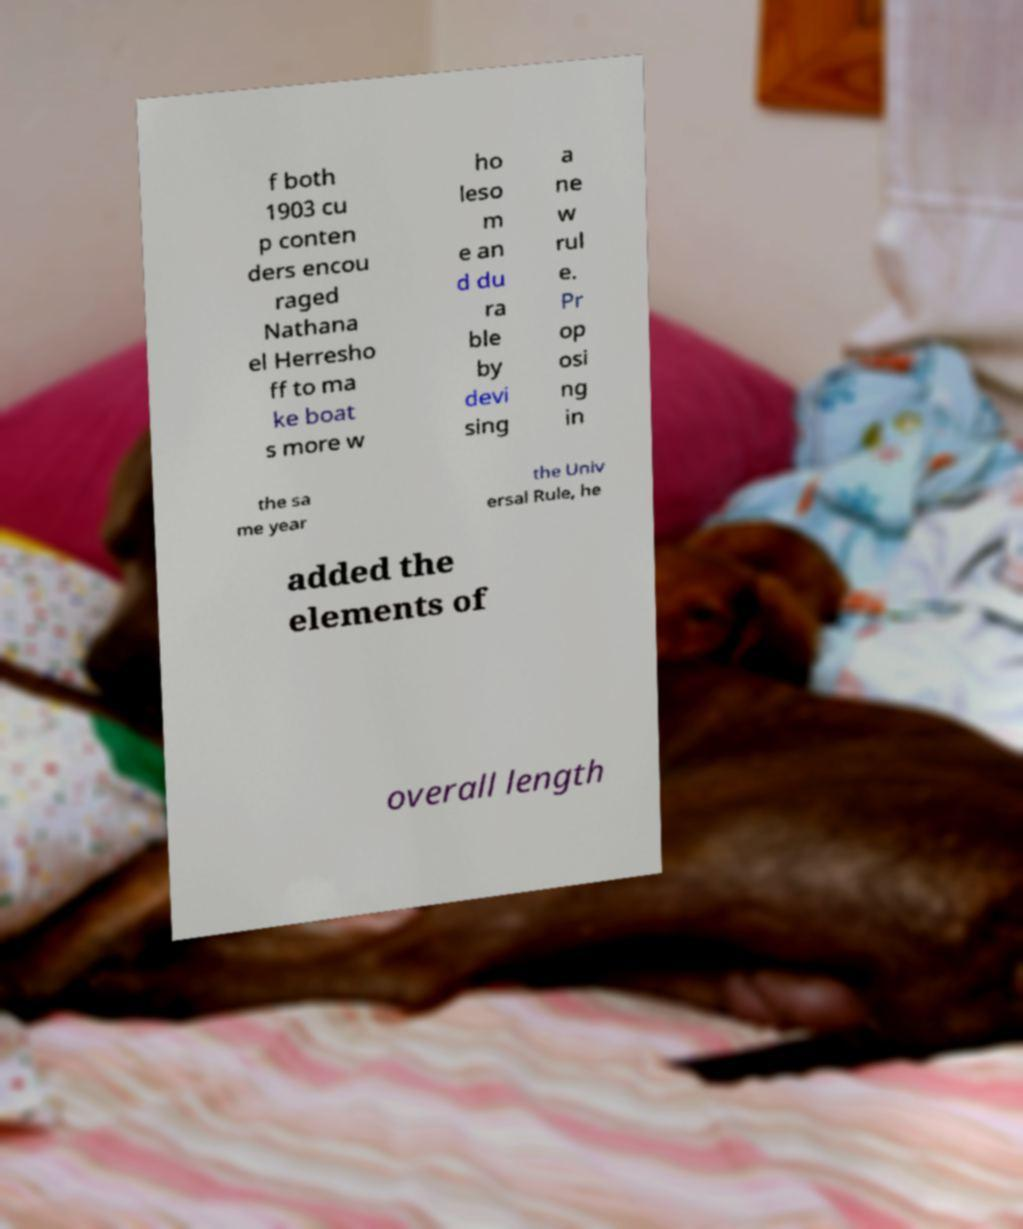Could you extract and type out the text from this image? f both 1903 cu p conten ders encou raged Nathana el Herresho ff to ma ke boat s more w ho leso m e an d du ra ble by devi sing a ne w rul e. Pr op osi ng in the sa me year the Univ ersal Rule, he added the elements of overall length 